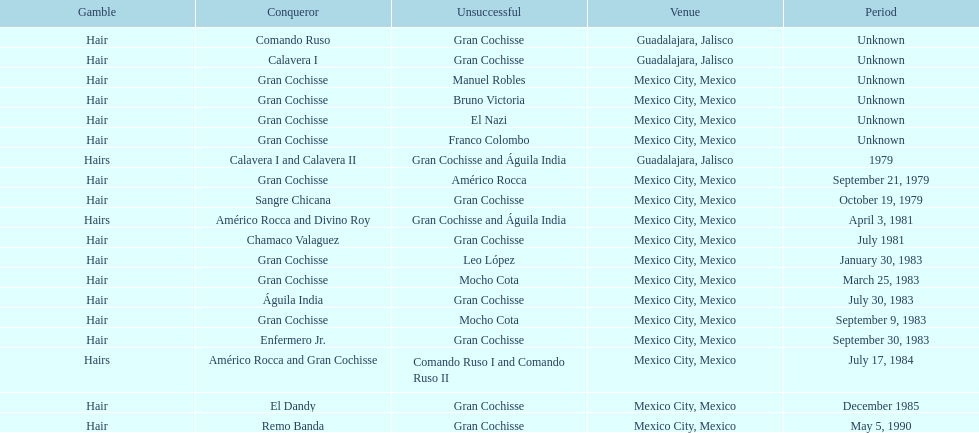When did bruno victoria lose his first game? Unknown. 